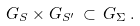<formula> <loc_0><loc_0><loc_500><loc_500>G _ { S } \times G _ { S ^ { \prime } } \, \subset \, G _ { \Sigma } \, .</formula> 